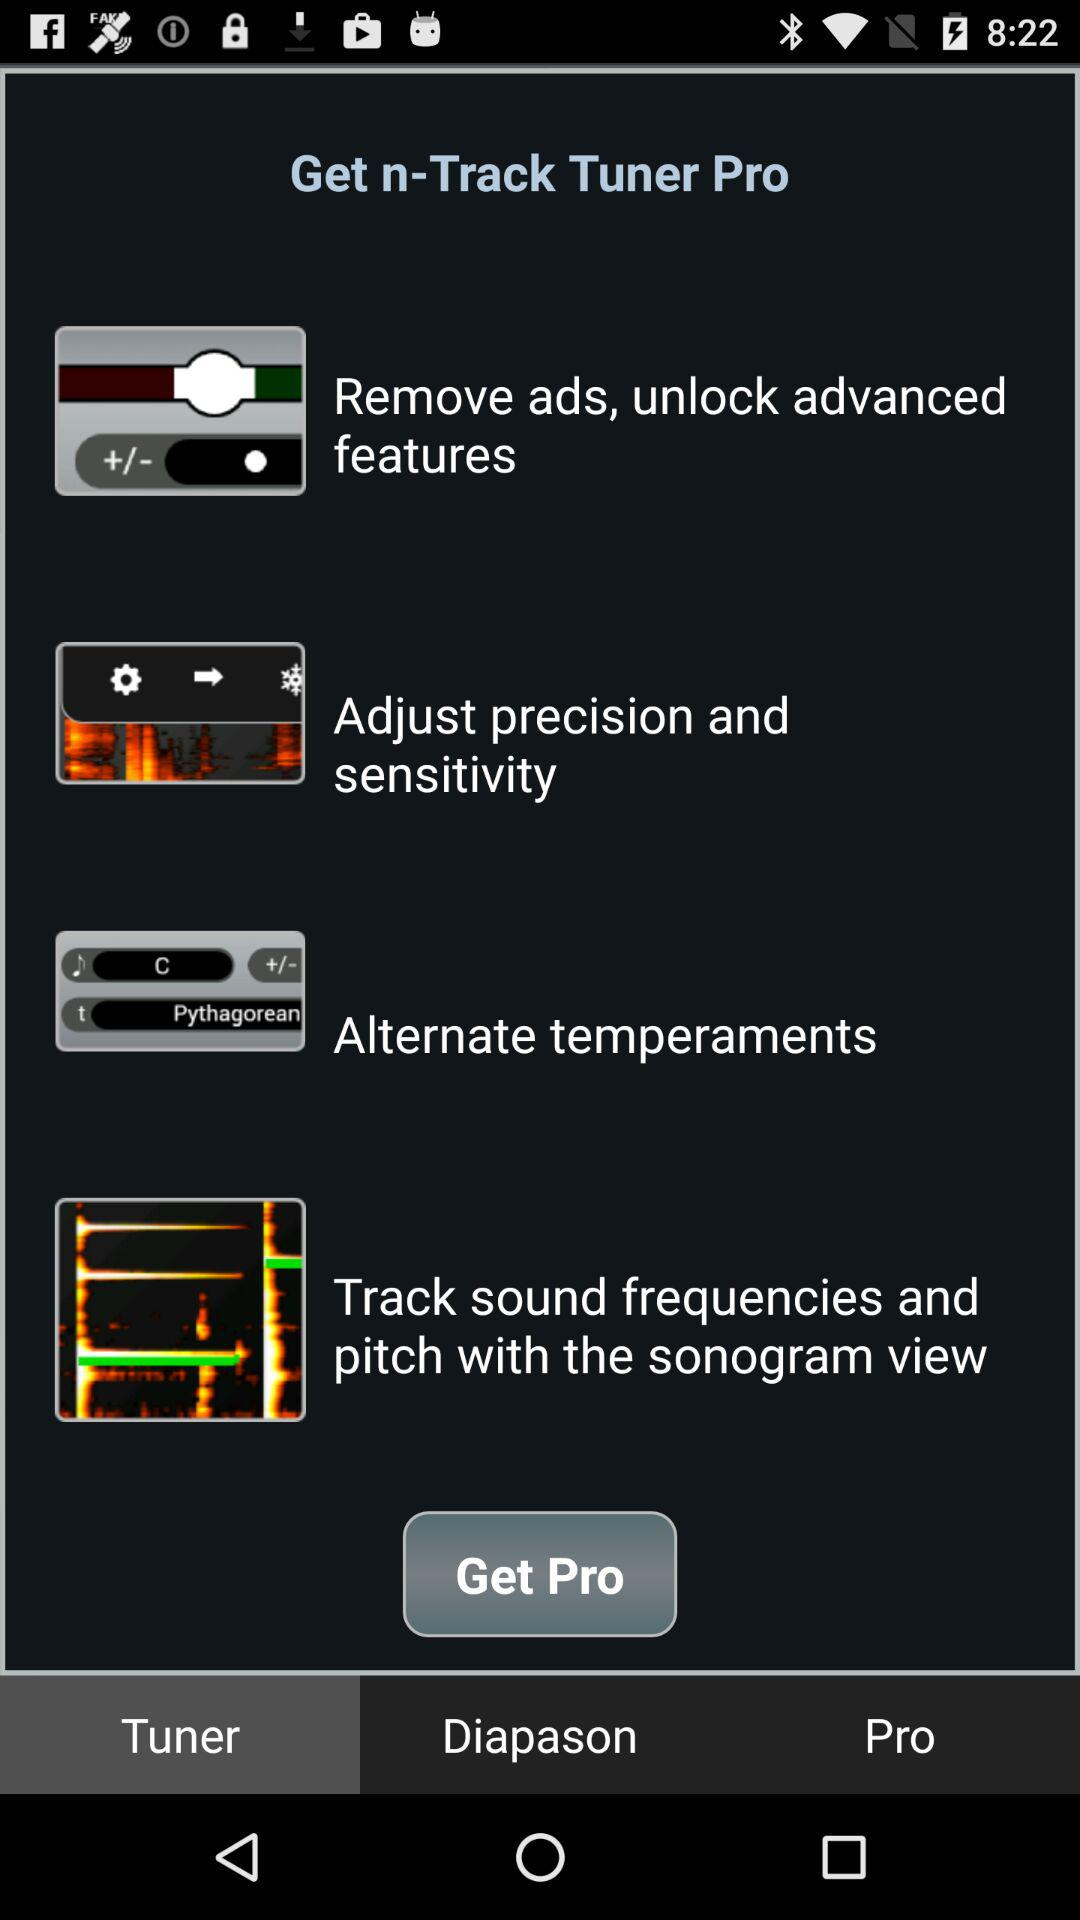What is the name of the application? The name of the application is "n-Track Tuner Pro". 